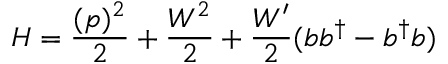<formula> <loc_0><loc_0><loc_500><loc_500>H = { \frac { ( p ) ^ { 2 } } { 2 } } + { \frac { { W } ^ { 2 } } { 2 } } + { \frac { W ^ { \prime } } { 2 } } ( b b ^ { \dagger } - b ^ { \dagger } b )</formula> 